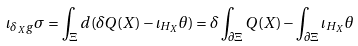<formula> <loc_0><loc_0><loc_500><loc_500>\iota _ { \delta _ { X } g } \sigma = \int _ { \Xi } d ( \delta Q ( X ) - \iota _ { H _ { X } } \theta ) = \delta \int _ { \partial \Xi } Q ( X ) - \int _ { \partial \Xi } \iota _ { H _ { X } } \theta</formula> 